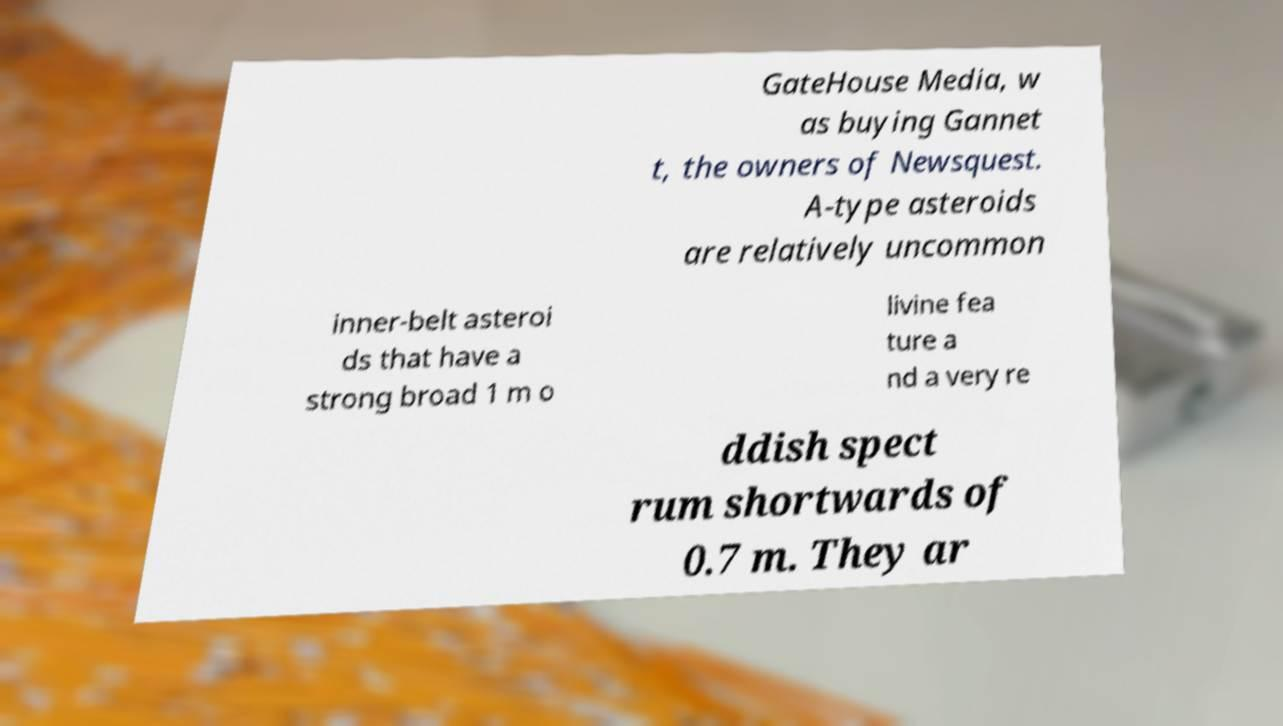For documentation purposes, I need the text within this image transcribed. Could you provide that? GateHouse Media, w as buying Gannet t, the owners of Newsquest. A-type asteroids are relatively uncommon inner-belt asteroi ds that have a strong broad 1 m o livine fea ture a nd a very re ddish spect rum shortwards of 0.7 m. They ar 